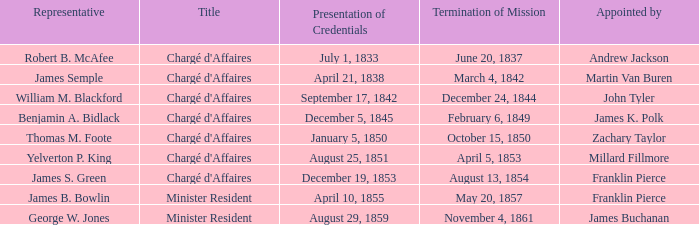Which representative has a credential presentation on april 10, 1855? James B. Bowlin. 